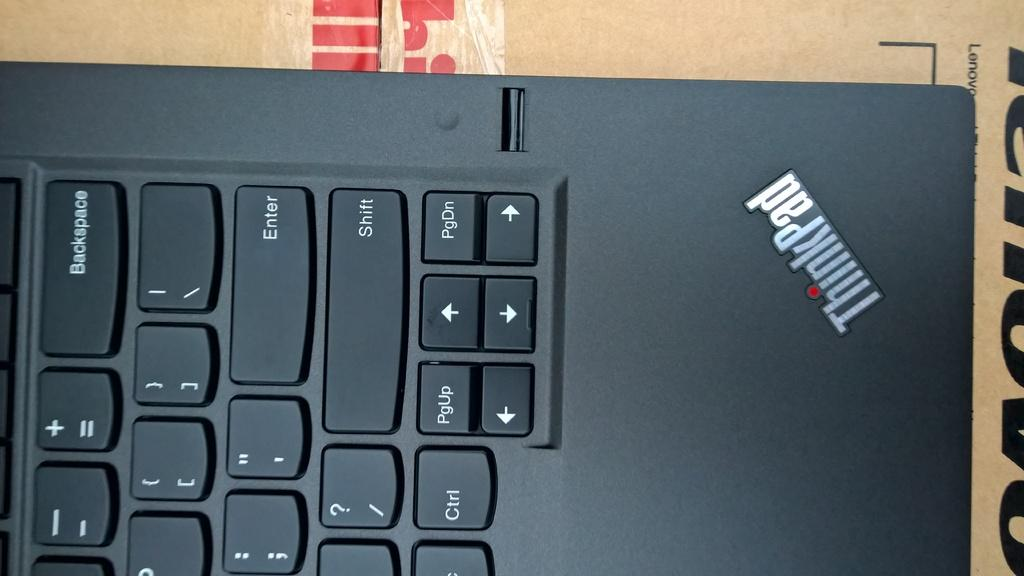<image>
Offer a succinct explanation of the picture presented. A bottom right corner of ThinkPad laptop keyboard. 